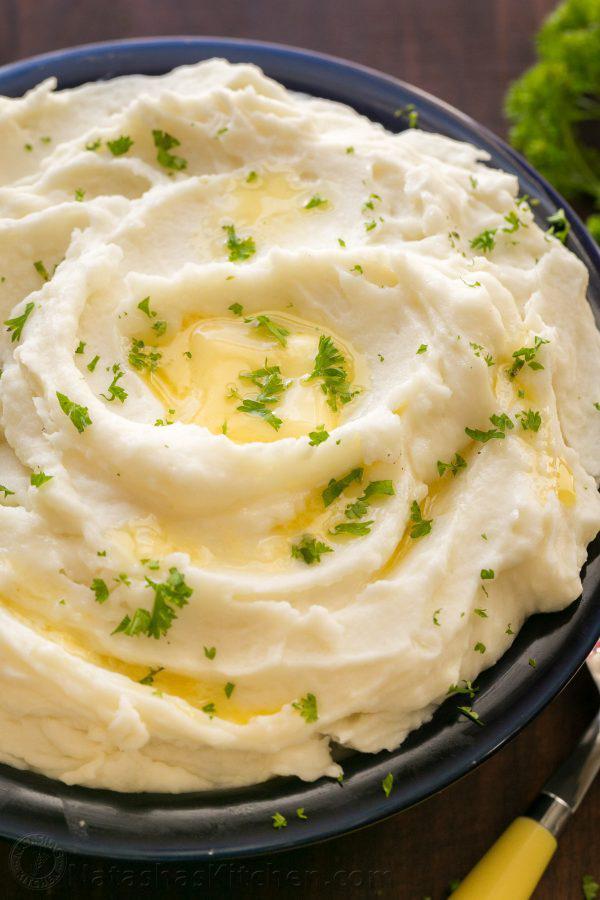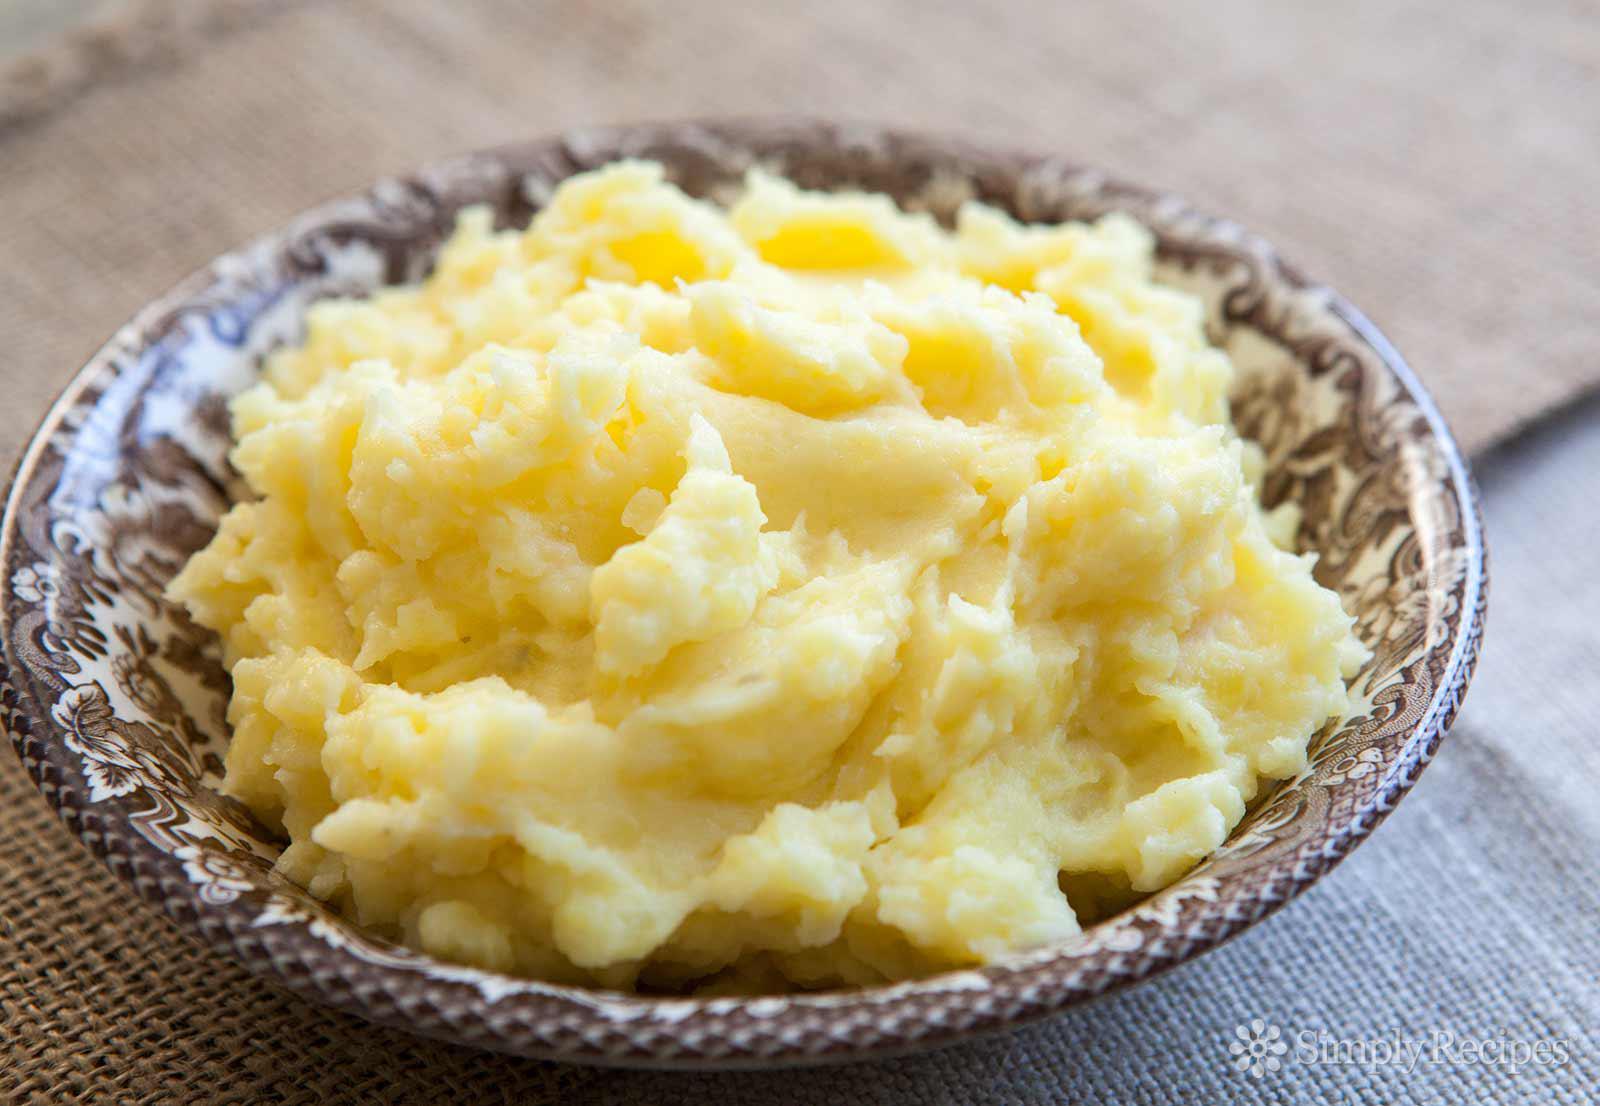The first image is the image on the left, the second image is the image on the right. For the images displayed, is the sentence "The mashed potatoes on the right have a spoon handle visibly sticking out of them" factually correct? Answer yes or no. No. The first image is the image on the left, the second image is the image on the right. For the images displayed, is the sentence "At least one image has a bowl of mashed potatoes, garnished with parsley, and parlest visible on the dark wooden surface beside the bowl." factually correct? Answer yes or no. Yes. 